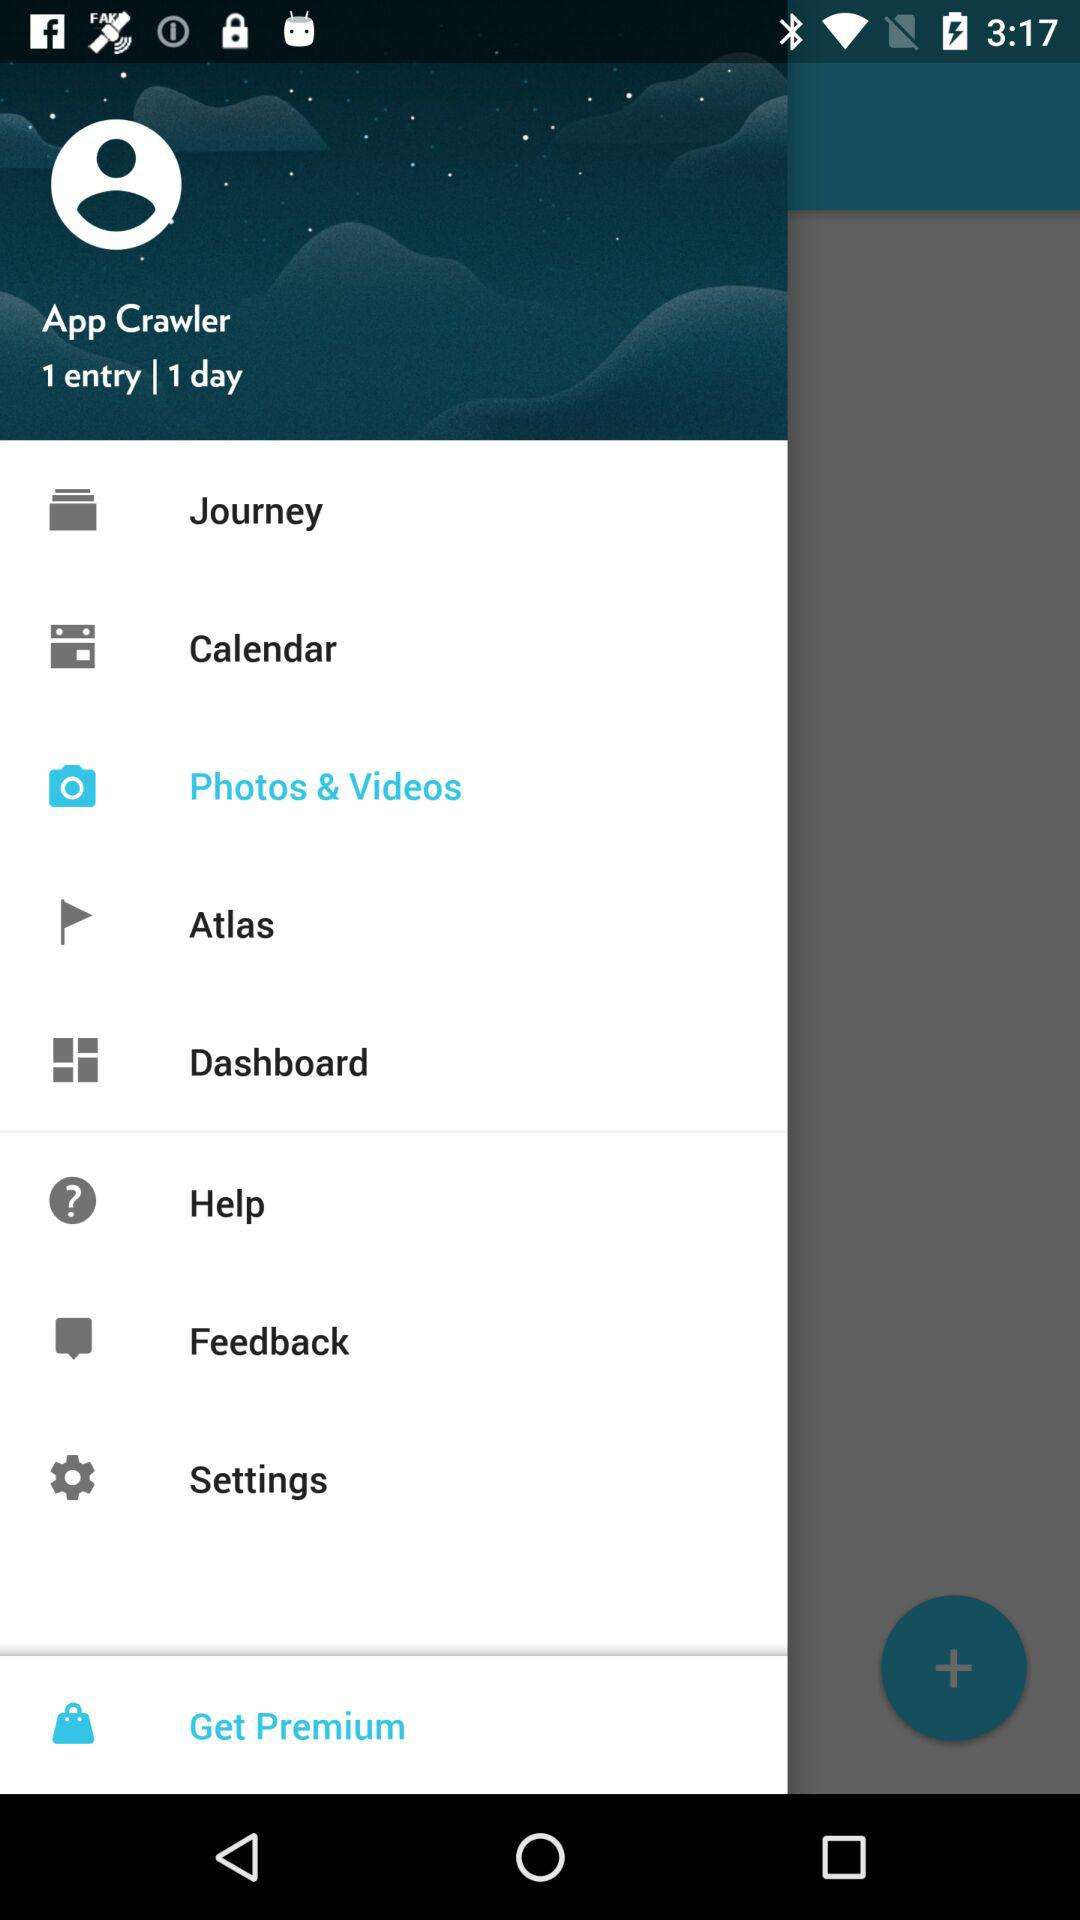Which option has been selected? The option that has been selected is "Photos & Videos". 